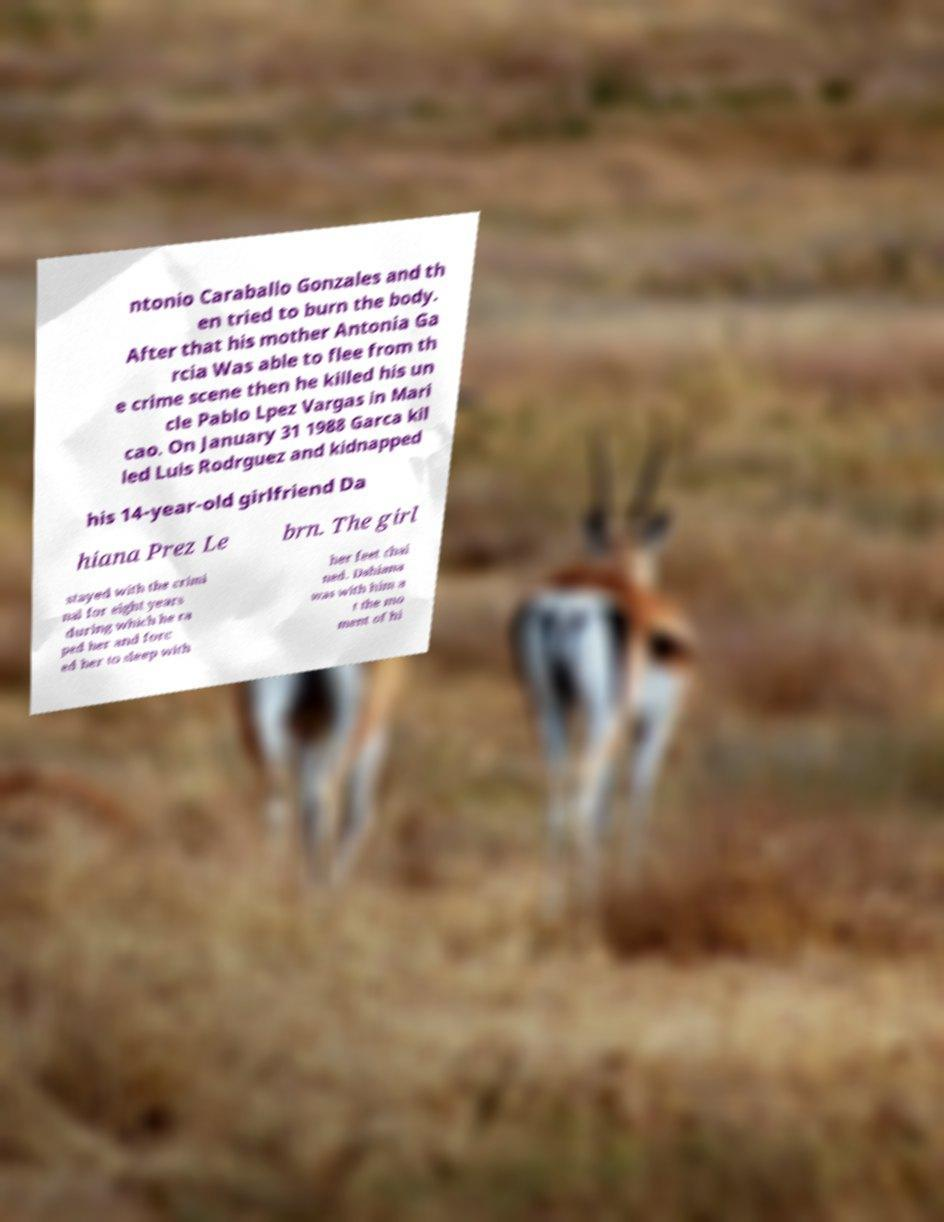Can you read and provide the text displayed in the image?This photo seems to have some interesting text. Can you extract and type it out for me? ntonio Caraballo Gonzales and th en tried to burn the body. After that his mother Antonia Ga rcia Was able to flee from th e crime scene then he killed his un cle Pablo Lpez Vargas in Mari cao. On January 31 1988 Garca kil led Luis Rodrguez and kidnapped his 14-year-old girlfriend Da hiana Prez Le brn. The girl stayed with the crimi nal for eight years during which he ra ped her and forc ed her to sleep with her feet chai ned. Dahiana was with him a t the mo ment of hi 